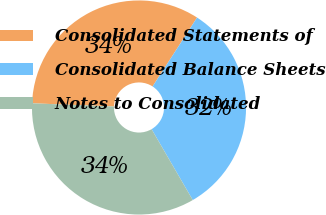Convert chart. <chart><loc_0><loc_0><loc_500><loc_500><pie_chart><fcel>Consolidated Statements of<fcel>Consolidated Balance Sheets<fcel>Notes to Consolidated<nl><fcel>33.5%<fcel>32.5%<fcel>34.0%<nl></chart> 